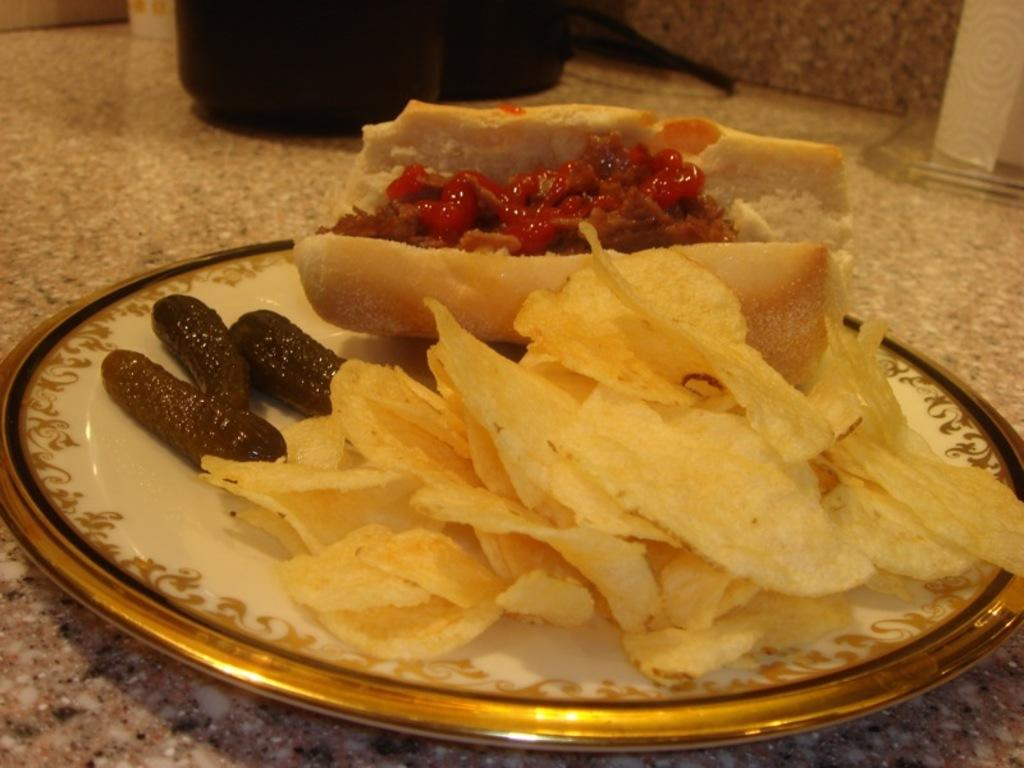What is the color of the object on the platform? The object on the platform is black. What is on the plate in the image? There is food on a plate, including chips. What direction is the sky facing in the image? There is no sky visible in the image, so it is not possible to determine the direction it might be facing. 